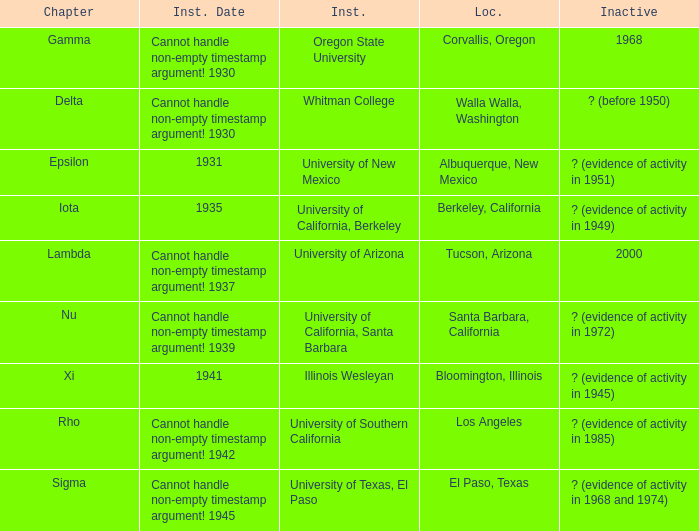What is the installation date for the Delta Chapter? Cannot handle non-empty timestamp argument! 1930. 